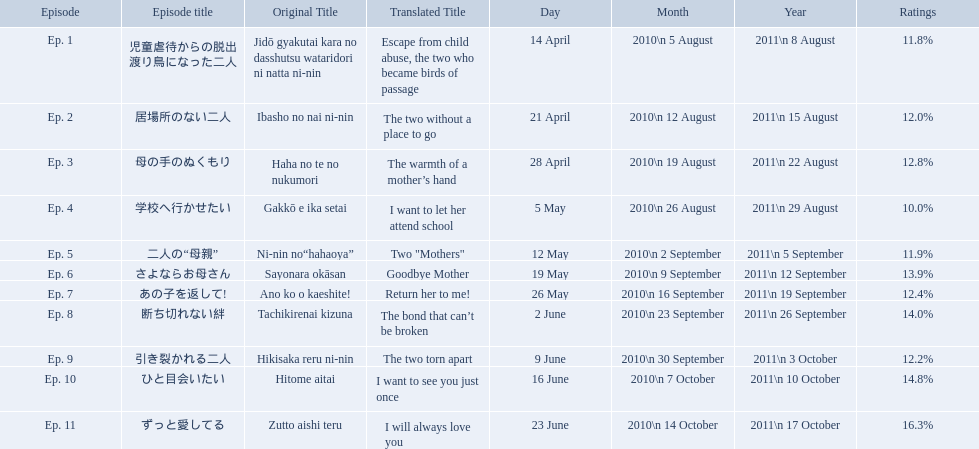What are all the episodes? Ep. 1, Ep. 2, Ep. 3, Ep. 4, Ep. 5, Ep. 6, Ep. 7, Ep. 8, Ep. 9, Ep. 10, Ep. 11. Of these, which ones have a rating of 14%? Ep. 8, Ep. 10. Of these, which one is not ep. 10? Ep. 8. What are the episodes of mother? 児童虐待からの脱出 渡り鳥になった二人, 居場所のない二人, 母の手のぬくもり, 学校へ行かせたい, 二人の“母親”, さよならお母さん, あの子を返して!, 断ち切れない絆, 引き裂かれる二人, ひと目会いたい, ずっと愛してる. What is the rating of episode 10? 14.8%. What is the other rating also in the 14 to 15 range? Ep. 8. What is the name of epsiode 8? 断ち切れない絆. What were this episodes ratings? 14.0%. How many total episodes are there? Ep. 1, Ep. 2, Ep. 3, Ep. 4, Ep. 5, Ep. 6, Ep. 7, Ep. 8, Ep. 9, Ep. 10, Ep. 11. Of those episodes, which one has the title of the bond that can't be broken? Ep. 8. What was the ratings percentage for that episode? 14.0%. What are the episode numbers? Ep. 1, Ep. 2, Ep. 3, Ep. 4, Ep. 5, Ep. 6, Ep. 7, Ep. 8, Ep. 9, Ep. 10, Ep. 11. What was the percentage of total ratings for episode 8? 14.0%. What were all the episode titles for the show mother? 児童虐待からの脱出 渡り鳥になった二人, 居場所のない二人, 母の手のぬくもり, 学校へ行かせたい, 二人の“母親”, さよならお母さん, あの子を返して!, 断ち切れない絆, 引き裂かれる二人, ひと目会いたい, ずっと愛してる. What were all the translated episode titles for the show mother? Escape from child abuse, the two who became birds of passage, The two without a place to go, The warmth of a mother’s hand, I want to let her attend school, Two "Mothers", Goodbye Mother, Return her to me!, The bond that can’t be broken, The two torn apart, I want to see you just once, I will always love you. Which episode was translated to i want to let her attend school? Ep. 4. Which episode was titled the two without a place to go? Ep. 2. What was the title of ep. 3? The warmth of a mother’s hand. Which episode had a rating of 10.0%? Ep. 4. Can you give me this table in json format? {'header': ['Episode', 'Episode title', 'Original Title', 'Translated Title', 'Day', 'Month', 'Year', 'Ratings'], 'rows': [['Ep. 1', '児童虐待からの脱出 渡り鳥になった二人', 'Jidō gyakutai kara no dasshutsu wataridori ni natta ni-nin', 'Escape from child abuse, the two who became birds of passage', '14 April', '2010\\n 5 August', '2011\\n 8 August', '11.8%'], ['Ep. 2', '居場所のない二人', 'Ibasho no nai ni-nin', 'The two without a place to go', '21 April', '2010\\n 12 August', '2011\\n 15 August', '12.0%'], ['Ep. 3', '母の手のぬくもり', 'Haha no te no nukumori', 'The warmth of a mother’s hand', '28 April', '2010\\n 19 August', '2011\\n 22 August', '12.8%'], ['Ep. 4', '学校へ行かせたい', 'Gakkō e ika setai', 'I want to let her attend school', '5 May', '2010\\n 26 August', '2011\\n 29 August', '10.0%'], ['Ep. 5', '二人の“母親”', 'Ni-nin no“hahaoya”', 'Two "Mothers"', '12 May', '2010\\n 2 September', '2011\\n 5 September', '11.9%'], ['Ep. 6', 'さよならお母さん', 'Sayonara okāsan', 'Goodbye Mother', '19 May', '2010\\n 9 September', '2011\\n 12 September', '13.9%'], ['Ep. 7', 'あの子を返して!', 'Ano ko o kaeshite!', 'Return her to me!', '26 May', '2010\\n 16 September', '2011\\n 19 September', '12.4%'], ['Ep. 8', '断ち切れない絆', 'Tachikirenai kizuna', 'The bond that can’t be broken', '2 June', '2010\\n 23 September', '2011\\n 26 September', '14.0%'], ['Ep. 9', '引き裂かれる二人', 'Hikisaka reru ni-nin', 'The two torn apart', '9 June', '2010\\n 30 September', '2011\\n 3 October', '12.2%'], ['Ep. 10', 'ひと目会いたい', 'Hitome aitai', 'I want to see you just once', '16 June', '2010\\n 7 October', '2011\\n 10 October', '14.8%'], ['Ep. 11', 'ずっと愛してる', 'Zutto aishi teru', 'I will always love you', '23 June', '2010\\n 14 October', '2011\\n 17 October', '16.3%']]} What are the rating percentages for each episode? 11.8%, 12.0%, 12.8%, 10.0%, 11.9%, 13.9%, 12.4%, 14.0%, 12.2%, 14.8%, 16.3%. What is the highest rating an episode got? 16.3%. What episode got a rating of 16.3%? ずっと愛してる. 